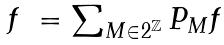<formula> <loc_0><loc_0><loc_500><loc_500>\begin{array} { l l } f & = \sum _ { M \in 2 ^ { \mathbb { Z } } } P _ { M } f \end{array}</formula> 